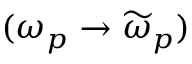<formula> <loc_0><loc_0><loc_500><loc_500>( \omega _ { p } \rightarrow \widetilde { \omega } _ { p } )</formula> 